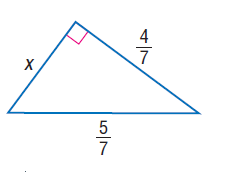Question: Find x.
Choices:
A. \frac { 1 } { 7 }
B. \frac { 3 } { 7 }
C. \frac { 4 } { 7 }
D. \frac { 5 } { 7 }
Answer with the letter. Answer: B 